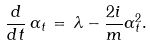<formula> <loc_0><loc_0><loc_500><loc_500>\frac { d } { d t } \, \alpha _ { t } \, = \, \lambda - \frac { 2 i } { m } \alpha ^ { 2 } _ { t } .</formula> 